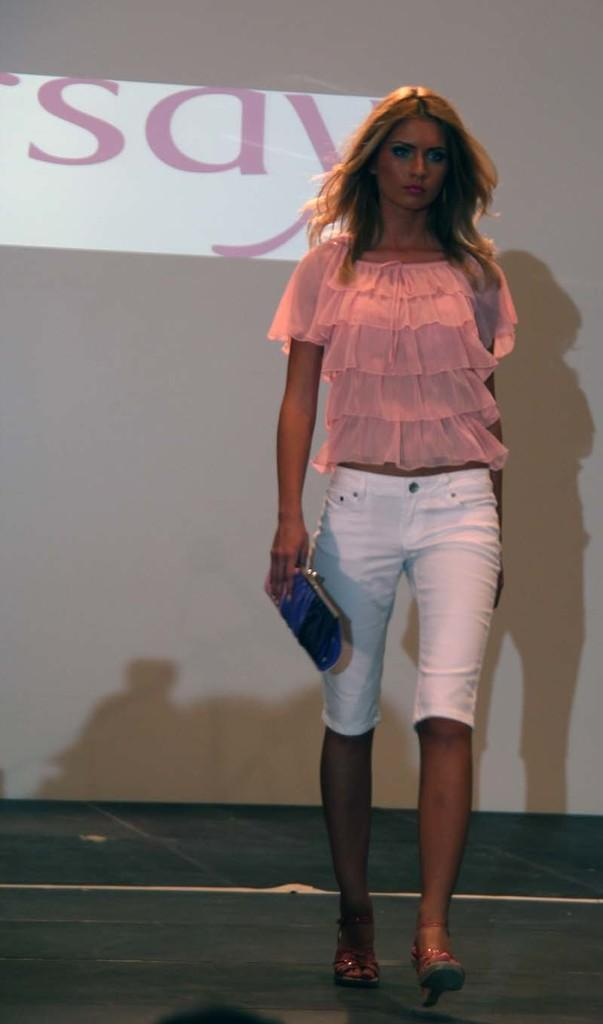Who is the main subject in the image? There is a lady in the image. What is the lady holding in the image? The lady is holding a wallet. What is the lady doing in the image? The lady is walking. What can be seen in the background of the image? There is a board in the background of the image. What type of thing is the lady trying to open with a drawer on the side in the image? There is no such object or action present in the image. 